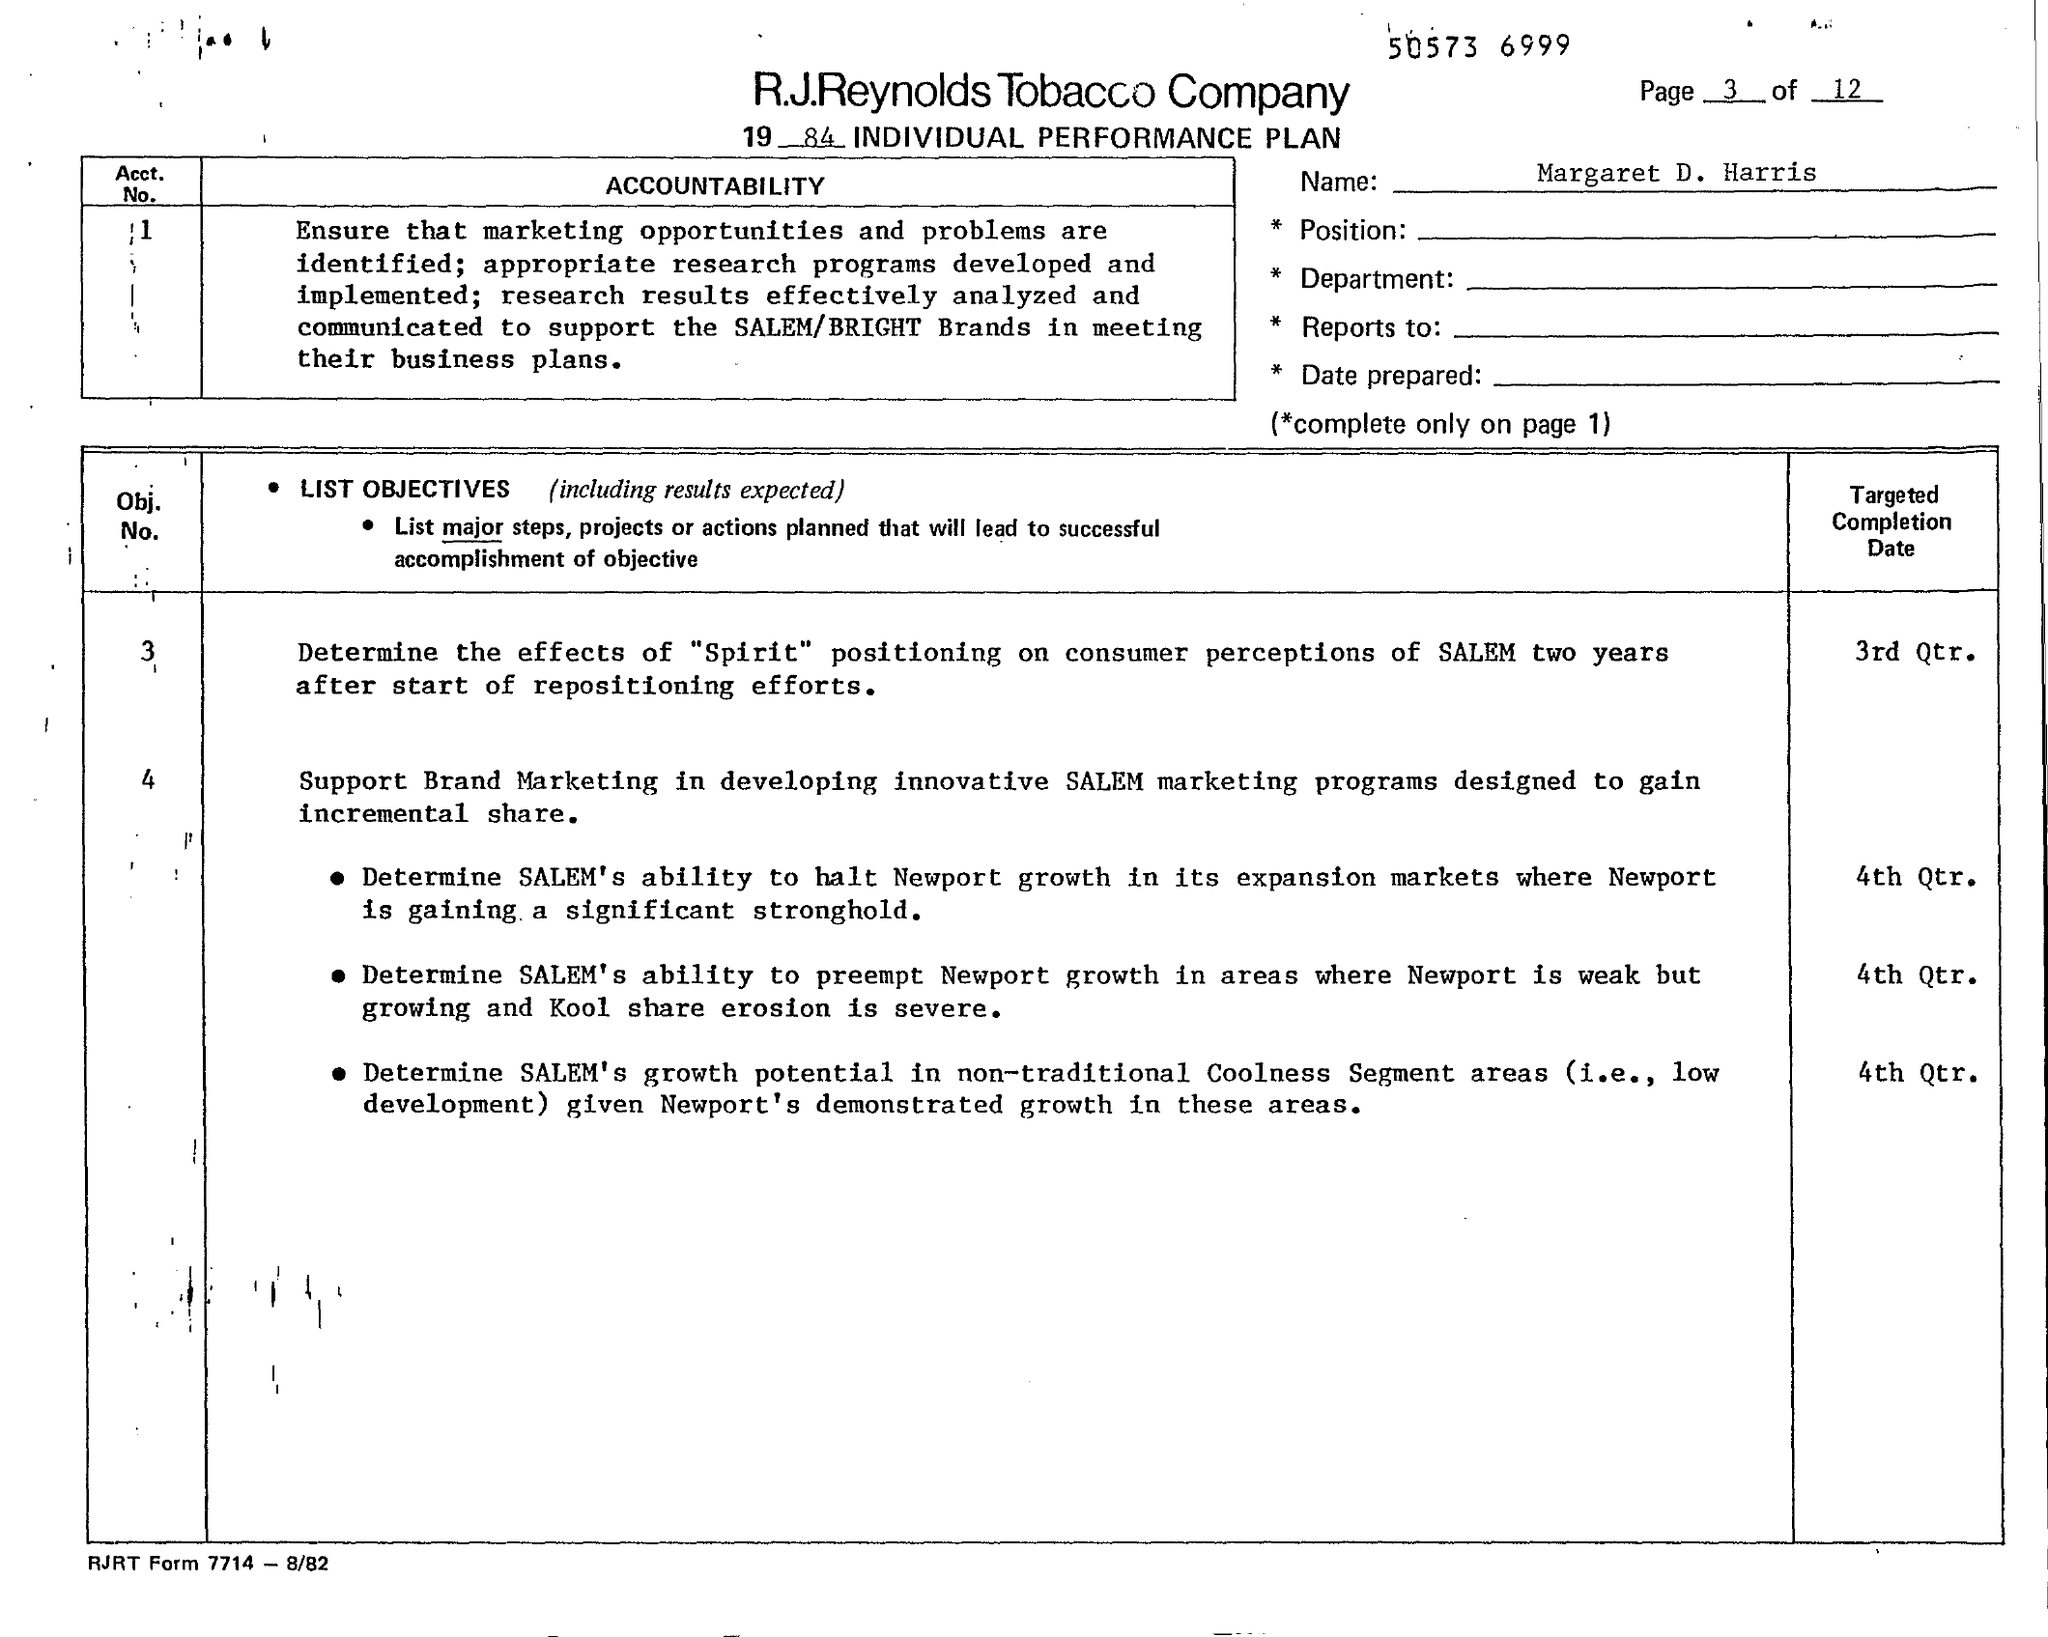What is the Name?
Give a very brief answer. Margaret d. harris. 